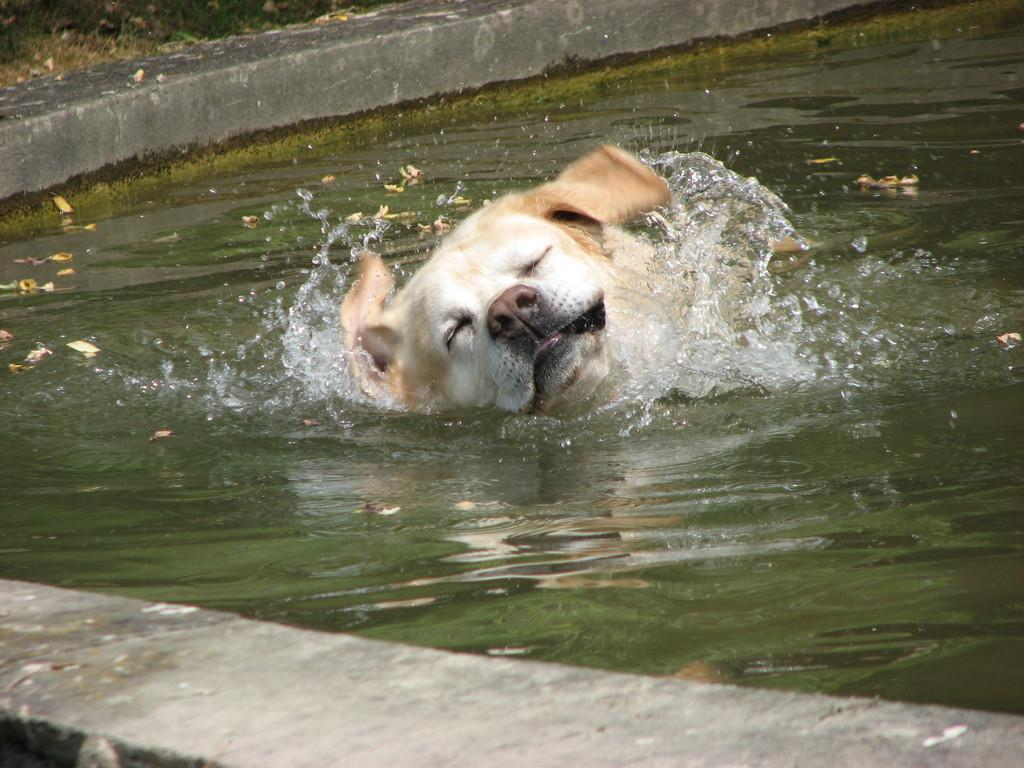What animal can be seen in the image? There is a dog in the image. What is the dog doing in the image? The dog is swimming in the water. What color is the dog in the image? The dog is cream colored. What type of lumber is being used to build the doghouse in the image? There is no doghouse present in the image, so it is not possible to determine what type of lumber is being used. 